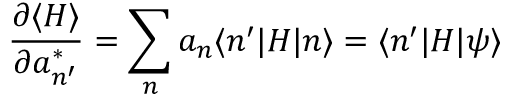Convert formula to latex. <formula><loc_0><loc_0><loc_500><loc_500>{ \frac { \partial \langle H \rangle } { \partial a _ { n ^ { \prime } } ^ { * } } } = \sum _ { n } a _ { n } \langle n ^ { \prime } | H | n \rangle = \langle n ^ { \prime } | H | \psi \rangle</formula> 